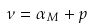<formula> <loc_0><loc_0><loc_500><loc_500>\nu = \alpha _ { M } + p</formula> 